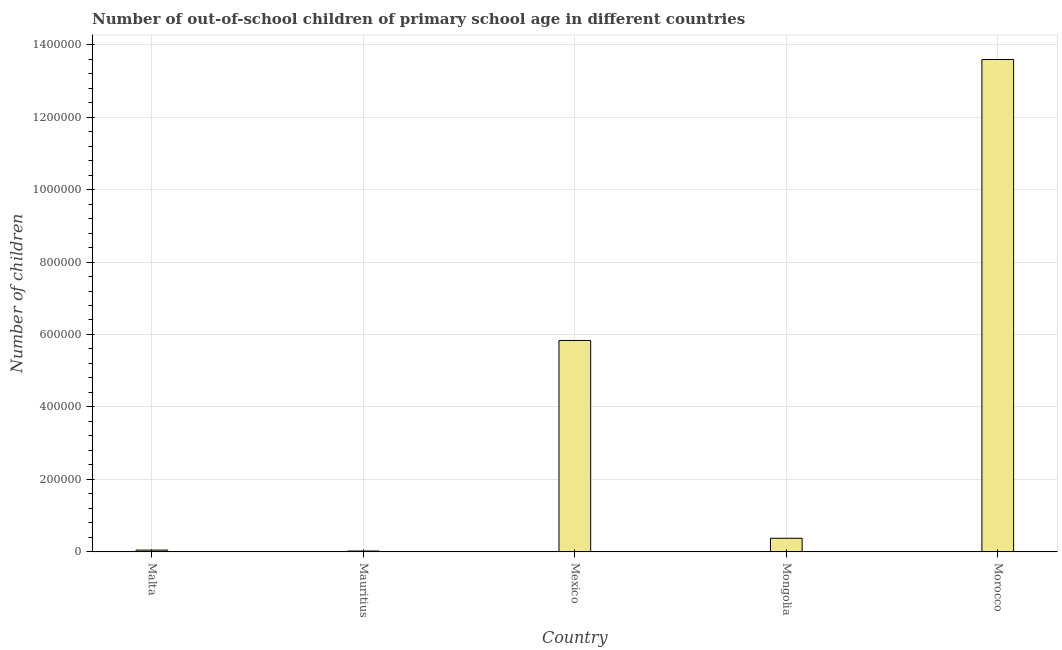Does the graph contain any zero values?
Give a very brief answer. No. Does the graph contain grids?
Provide a short and direct response. Yes. What is the title of the graph?
Ensure brevity in your answer.  Number of out-of-school children of primary school age in different countries. What is the label or title of the X-axis?
Offer a very short reply. Country. What is the label or title of the Y-axis?
Offer a terse response. Number of children. What is the number of out-of-school children in Morocco?
Keep it short and to the point. 1.36e+06. Across all countries, what is the maximum number of out-of-school children?
Keep it short and to the point. 1.36e+06. Across all countries, what is the minimum number of out-of-school children?
Provide a succinct answer. 2552. In which country was the number of out-of-school children maximum?
Your answer should be compact. Morocco. In which country was the number of out-of-school children minimum?
Give a very brief answer. Mauritius. What is the sum of the number of out-of-school children?
Keep it short and to the point. 1.99e+06. What is the difference between the number of out-of-school children in Mexico and Mongolia?
Your response must be concise. 5.46e+05. What is the average number of out-of-school children per country?
Offer a terse response. 3.98e+05. What is the median number of out-of-school children?
Keep it short and to the point. 3.77e+04. What is the ratio of the number of out-of-school children in Malta to that in Mexico?
Your answer should be very brief. 0.01. Is the number of out-of-school children in Malta less than that in Mexico?
Provide a short and direct response. Yes. Is the difference between the number of out-of-school children in Mongolia and Morocco greater than the difference between any two countries?
Your response must be concise. No. What is the difference between the highest and the second highest number of out-of-school children?
Provide a succinct answer. 7.75e+05. What is the difference between the highest and the lowest number of out-of-school children?
Your answer should be very brief. 1.36e+06. In how many countries, is the number of out-of-school children greater than the average number of out-of-school children taken over all countries?
Offer a terse response. 2. Are all the bars in the graph horizontal?
Make the answer very short. No. How many countries are there in the graph?
Keep it short and to the point. 5. What is the difference between two consecutive major ticks on the Y-axis?
Offer a very short reply. 2.00e+05. What is the Number of children of Malta?
Your response must be concise. 5092. What is the Number of children in Mauritius?
Provide a short and direct response. 2552. What is the Number of children in Mexico?
Offer a very short reply. 5.84e+05. What is the Number of children of Mongolia?
Your response must be concise. 3.77e+04. What is the Number of children in Morocco?
Ensure brevity in your answer.  1.36e+06. What is the difference between the Number of children in Malta and Mauritius?
Your answer should be very brief. 2540. What is the difference between the Number of children in Malta and Mexico?
Your answer should be compact. -5.78e+05. What is the difference between the Number of children in Malta and Mongolia?
Your answer should be very brief. -3.26e+04. What is the difference between the Number of children in Malta and Morocco?
Your answer should be very brief. -1.35e+06. What is the difference between the Number of children in Mauritius and Mexico?
Keep it short and to the point. -5.81e+05. What is the difference between the Number of children in Mauritius and Mongolia?
Your answer should be very brief. -3.52e+04. What is the difference between the Number of children in Mauritius and Morocco?
Keep it short and to the point. -1.36e+06. What is the difference between the Number of children in Mexico and Mongolia?
Your answer should be very brief. 5.46e+05. What is the difference between the Number of children in Mexico and Morocco?
Make the answer very short. -7.75e+05. What is the difference between the Number of children in Mongolia and Morocco?
Offer a very short reply. -1.32e+06. What is the ratio of the Number of children in Malta to that in Mauritius?
Your answer should be very brief. 2. What is the ratio of the Number of children in Malta to that in Mexico?
Keep it short and to the point. 0.01. What is the ratio of the Number of children in Malta to that in Mongolia?
Offer a terse response. 0.14. What is the ratio of the Number of children in Malta to that in Morocco?
Provide a short and direct response. 0. What is the ratio of the Number of children in Mauritius to that in Mexico?
Your answer should be compact. 0. What is the ratio of the Number of children in Mauritius to that in Mongolia?
Your answer should be very brief. 0.07. What is the ratio of the Number of children in Mauritius to that in Morocco?
Your response must be concise. 0. What is the ratio of the Number of children in Mexico to that in Mongolia?
Provide a succinct answer. 15.46. What is the ratio of the Number of children in Mexico to that in Morocco?
Give a very brief answer. 0.43. What is the ratio of the Number of children in Mongolia to that in Morocco?
Provide a short and direct response. 0.03. 